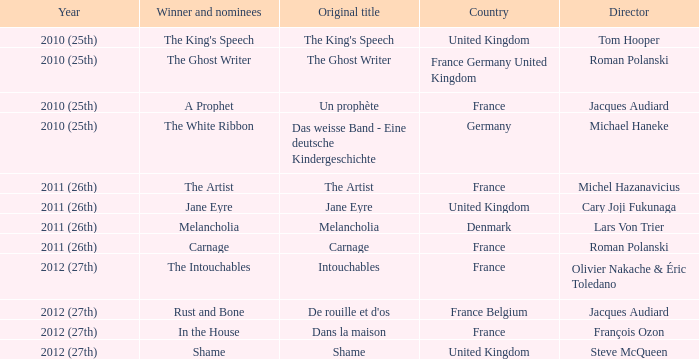Could you parse the entire table as a dict? {'header': ['Year', 'Winner and nominees', 'Original title', 'Country', 'Director'], 'rows': [['2010 (25th)', "The King's Speech", "The King's Speech", 'United Kingdom', 'Tom Hooper'], ['2010 (25th)', 'The Ghost Writer', 'The Ghost Writer', 'France Germany United Kingdom', 'Roman Polanski'], ['2010 (25th)', 'A Prophet', 'Un prophète', 'France', 'Jacques Audiard'], ['2010 (25th)', 'The White Ribbon', 'Das weisse Band - Eine deutsche Kindergeschichte', 'Germany', 'Michael Haneke'], ['2011 (26th)', 'The Artist', 'The Artist', 'France', 'Michel Hazanavicius'], ['2011 (26th)', 'Jane Eyre', 'Jane Eyre', 'United Kingdom', 'Cary Joji Fukunaga'], ['2011 (26th)', 'Melancholia', 'Melancholia', 'Denmark', 'Lars Von Trier'], ['2011 (26th)', 'Carnage', 'Carnage', 'France', 'Roman Polanski'], ['2012 (27th)', 'The Intouchables', 'Intouchables', 'France', 'Olivier Nakache & Éric Toledano'], ['2012 (27th)', 'Rust and Bone', "De rouille et d'os", 'France Belgium', 'Jacques Audiard'], ['2012 (27th)', 'In the House', 'Dans la maison', 'France', 'François Ozon'], ['2012 (27th)', 'Shame', 'Shame', 'United Kingdom', 'Steve McQueen']]} What was the original title of the king's speech? The King's Speech. 